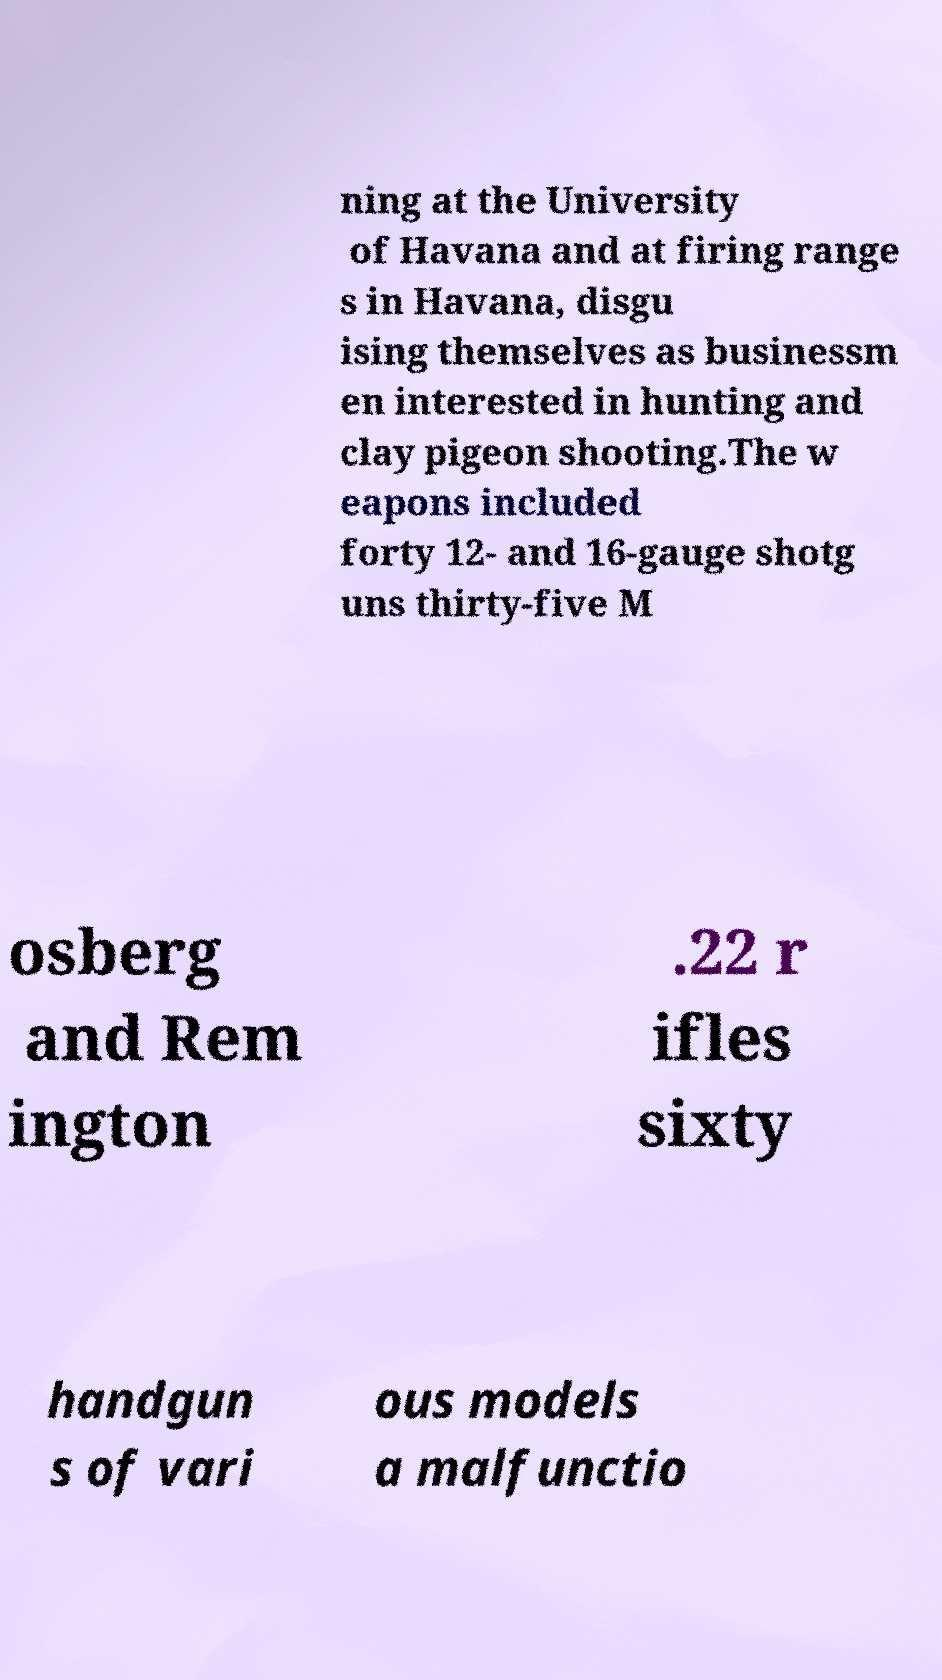Please read and relay the text visible in this image. What does it say? ning at the University of Havana and at firing range s in Havana, disgu ising themselves as businessm en interested in hunting and clay pigeon shooting.The w eapons included forty 12- and 16-gauge shotg uns thirty-five M osberg and Rem ington .22 r ifles sixty handgun s of vari ous models a malfunctio 